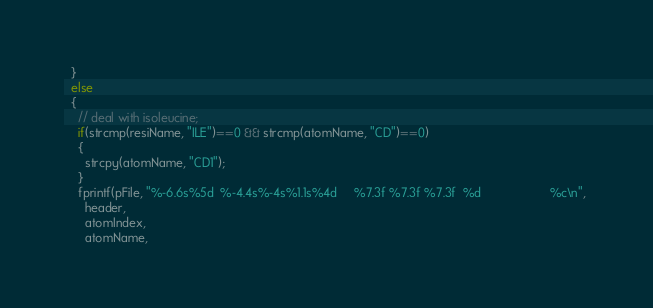Convert code to text. <code><loc_0><loc_0><loc_500><loc_500><_C++_>  }
  else
  {
    // deal with isoleucine;
    if(strcmp(resiName, "ILE")==0 && strcmp(atomName, "CD")==0)
    {
      strcpy(atomName, "CD1");
    }
    fprintf(pFile, "%-6.6s%5d  %-4.4s%-4s%1.1s%4d     %7.3f %7.3f %7.3f  %d                    %c\n", 
      header, 
      atomIndex, 
      atomName, </code> 